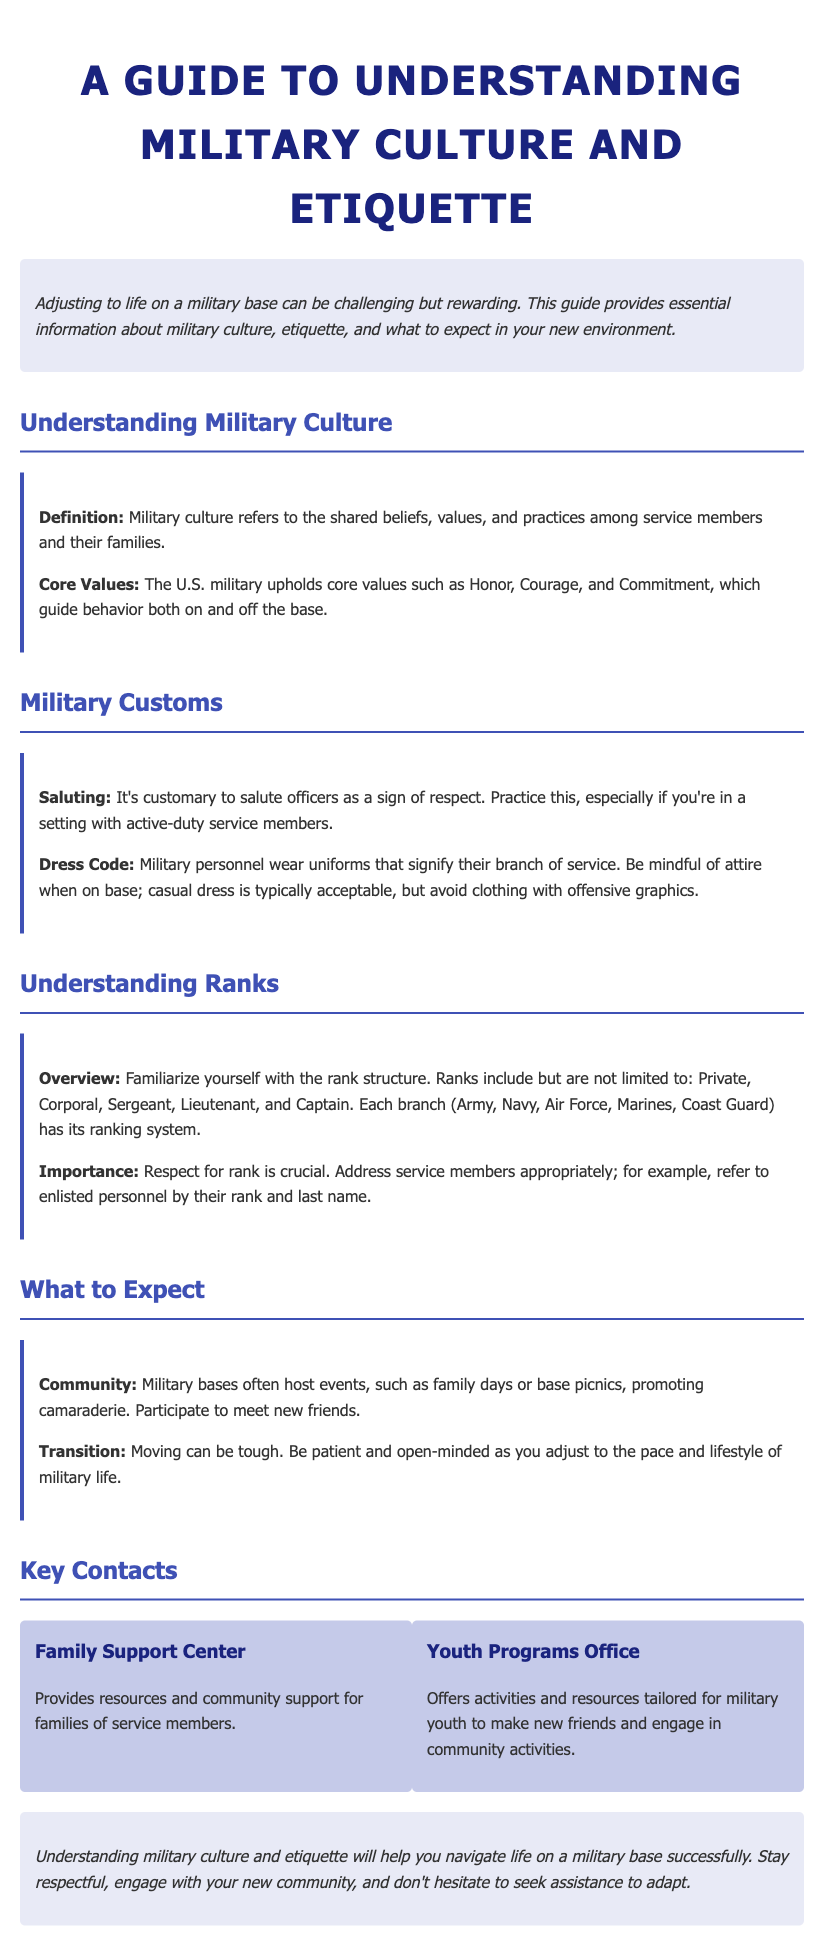what are the core values of the U.S. military? The core values mentioned in the document are Honor, Courage, and Commitment.
Answer: Honor, Courage, Commitment what should you do when you see an officer? The document states that it's customary to salute officers as a sign of respect.
Answer: Salute what are the ranks mentioned in the document? The ranks include Private, Corporal, Sergeant, Lieutenant, and Captain.
Answer: Private, Corporal, Sergeant, Lieutenant, Captain what type of events do military bases host? The document mentions family days or base picnics as events to promote camaraderie.
Answer: Family days, base picnics which office provides resources and support for military youth? The Youth Programs Office offers activities and resources tailored for military youth.
Answer: Youth Programs Office what is a key reason to engage with the new community? The document emphasizes participation in base events to meet new friends as a reason to engage.
Answer: To meet new friends what is emphasized about respect for rank? The importance of addressing service members appropriately by their rank and last name is emphasized.
Answer: Respect for rank what should you do to adapt to military life? The document advises being patient and open-minded as you adjust to the pace and lifestyle.
Answer: Be patient and open-minded 